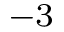<formula> <loc_0><loc_0><loc_500><loc_500>^ { - 3 }</formula> 